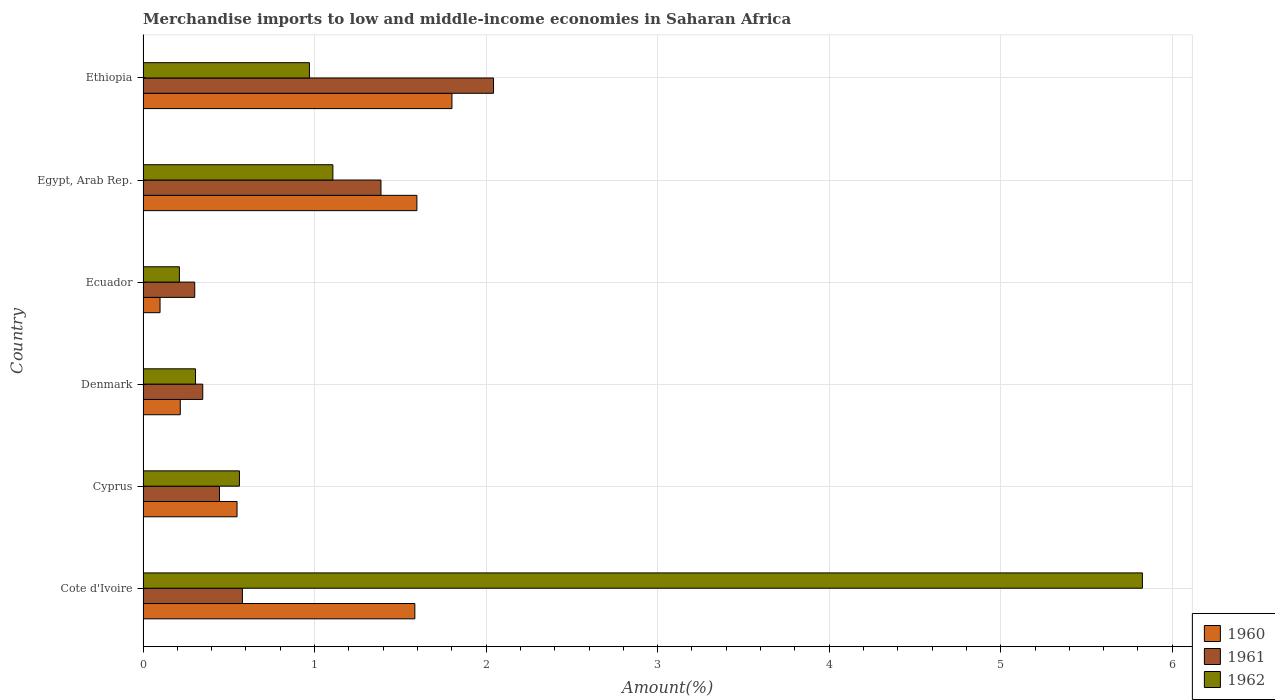Are the number of bars per tick equal to the number of legend labels?
Keep it short and to the point. Yes. Are the number of bars on each tick of the Y-axis equal?
Your answer should be compact. Yes. How many bars are there on the 4th tick from the top?
Offer a terse response. 3. How many bars are there on the 1st tick from the bottom?
Keep it short and to the point. 3. What is the label of the 5th group of bars from the top?
Make the answer very short. Cyprus. In how many cases, is the number of bars for a given country not equal to the number of legend labels?
Keep it short and to the point. 0. What is the percentage of amount earned from merchandise imports in 1962 in Cyprus?
Offer a very short reply. 0.56. Across all countries, what is the maximum percentage of amount earned from merchandise imports in 1961?
Keep it short and to the point. 2.04. Across all countries, what is the minimum percentage of amount earned from merchandise imports in 1960?
Make the answer very short. 0.1. In which country was the percentage of amount earned from merchandise imports in 1961 maximum?
Make the answer very short. Ethiopia. In which country was the percentage of amount earned from merchandise imports in 1962 minimum?
Your response must be concise. Ecuador. What is the total percentage of amount earned from merchandise imports in 1960 in the graph?
Your response must be concise. 5.85. What is the difference between the percentage of amount earned from merchandise imports in 1962 in Cote d'Ivoire and that in Cyprus?
Your answer should be compact. 5.26. What is the difference between the percentage of amount earned from merchandise imports in 1961 in Cyprus and the percentage of amount earned from merchandise imports in 1962 in Ethiopia?
Your answer should be compact. -0.52. What is the average percentage of amount earned from merchandise imports in 1961 per country?
Make the answer very short. 0.85. What is the difference between the percentage of amount earned from merchandise imports in 1960 and percentage of amount earned from merchandise imports in 1961 in Ecuador?
Your answer should be compact. -0.2. In how many countries, is the percentage of amount earned from merchandise imports in 1962 greater than 5.8 %?
Offer a terse response. 1. What is the ratio of the percentage of amount earned from merchandise imports in 1962 in Cyprus to that in Egypt, Arab Rep.?
Offer a very short reply. 0.51. Is the percentage of amount earned from merchandise imports in 1962 in Ecuador less than that in Ethiopia?
Provide a short and direct response. Yes. Is the difference between the percentage of amount earned from merchandise imports in 1960 in Cote d'Ivoire and Egypt, Arab Rep. greater than the difference between the percentage of amount earned from merchandise imports in 1961 in Cote d'Ivoire and Egypt, Arab Rep.?
Make the answer very short. Yes. What is the difference between the highest and the second highest percentage of amount earned from merchandise imports in 1961?
Give a very brief answer. 0.66. What is the difference between the highest and the lowest percentage of amount earned from merchandise imports in 1960?
Provide a succinct answer. 1.7. Is the sum of the percentage of amount earned from merchandise imports in 1961 in Cyprus and Ecuador greater than the maximum percentage of amount earned from merchandise imports in 1960 across all countries?
Your answer should be compact. No. Is it the case that in every country, the sum of the percentage of amount earned from merchandise imports in 1961 and percentage of amount earned from merchandise imports in 1962 is greater than the percentage of amount earned from merchandise imports in 1960?
Make the answer very short. Yes. How many bars are there?
Give a very brief answer. 18. How many countries are there in the graph?
Give a very brief answer. 6. What is the difference between two consecutive major ticks on the X-axis?
Your answer should be very brief. 1. Are the values on the major ticks of X-axis written in scientific E-notation?
Provide a short and direct response. No. Does the graph contain grids?
Offer a terse response. Yes. How many legend labels are there?
Make the answer very short. 3. How are the legend labels stacked?
Give a very brief answer. Vertical. What is the title of the graph?
Provide a succinct answer. Merchandise imports to low and middle-income economies in Saharan Africa. What is the label or title of the X-axis?
Your response must be concise. Amount(%). What is the label or title of the Y-axis?
Your answer should be compact. Country. What is the Amount(%) in 1960 in Cote d'Ivoire?
Offer a very short reply. 1.58. What is the Amount(%) in 1961 in Cote d'Ivoire?
Your response must be concise. 0.58. What is the Amount(%) of 1962 in Cote d'Ivoire?
Your answer should be very brief. 5.83. What is the Amount(%) of 1960 in Cyprus?
Keep it short and to the point. 0.55. What is the Amount(%) of 1961 in Cyprus?
Your answer should be very brief. 0.45. What is the Amount(%) of 1962 in Cyprus?
Your answer should be very brief. 0.56. What is the Amount(%) in 1960 in Denmark?
Offer a terse response. 0.22. What is the Amount(%) of 1961 in Denmark?
Your response must be concise. 0.35. What is the Amount(%) of 1962 in Denmark?
Your response must be concise. 0.31. What is the Amount(%) in 1960 in Ecuador?
Offer a very short reply. 0.1. What is the Amount(%) of 1961 in Ecuador?
Give a very brief answer. 0.3. What is the Amount(%) of 1962 in Ecuador?
Provide a short and direct response. 0.21. What is the Amount(%) in 1960 in Egypt, Arab Rep.?
Your answer should be very brief. 1.6. What is the Amount(%) in 1961 in Egypt, Arab Rep.?
Give a very brief answer. 1.39. What is the Amount(%) of 1962 in Egypt, Arab Rep.?
Ensure brevity in your answer.  1.11. What is the Amount(%) of 1960 in Ethiopia?
Provide a succinct answer. 1.8. What is the Amount(%) of 1961 in Ethiopia?
Give a very brief answer. 2.04. What is the Amount(%) of 1962 in Ethiopia?
Make the answer very short. 0.97. Across all countries, what is the maximum Amount(%) in 1960?
Offer a very short reply. 1.8. Across all countries, what is the maximum Amount(%) in 1961?
Offer a very short reply. 2.04. Across all countries, what is the maximum Amount(%) of 1962?
Offer a terse response. 5.83. Across all countries, what is the minimum Amount(%) of 1960?
Make the answer very short. 0.1. Across all countries, what is the minimum Amount(%) of 1961?
Your response must be concise. 0.3. Across all countries, what is the minimum Amount(%) of 1962?
Keep it short and to the point. 0.21. What is the total Amount(%) in 1960 in the graph?
Keep it short and to the point. 5.85. What is the total Amount(%) of 1961 in the graph?
Offer a terse response. 5.1. What is the total Amount(%) of 1962 in the graph?
Keep it short and to the point. 8.98. What is the difference between the Amount(%) of 1960 in Cote d'Ivoire and that in Cyprus?
Provide a succinct answer. 1.04. What is the difference between the Amount(%) of 1961 in Cote d'Ivoire and that in Cyprus?
Offer a terse response. 0.13. What is the difference between the Amount(%) in 1962 in Cote d'Ivoire and that in Cyprus?
Offer a terse response. 5.26. What is the difference between the Amount(%) in 1960 in Cote d'Ivoire and that in Denmark?
Make the answer very short. 1.37. What is the difference between the Amount(%) of 1961 in Cote d'Ivoire and that in Denmark?
Give a very brief answer. 0.23. What is the difference between the Amount(%) in 1962 in Cote d'Ivoire and that in Denmark?
Offer a terse response. 5.52. What is the difference between the Amount(%) in 1960 in Cote d'Ivoire and that in Ecuador?
Provide a succinct answer. 1.49. What is the difference between the Amount(%) of 1961 in Cote d'Ivoire and that in Ecuador?
Offer a terse response. 0.28. What is the difference between the Amount(%) of 1962 in Cote d'Ivoire and that in Ecuador?
Offer a terse response. 5.61. What is the difference between the Amount(%) in 1960 in Cote d'Ivoire and that in Egypt, Arab Rep.?
Ensure brevity in your answer.  -0.01. What is the difference between the Amount(%) in 1961 in Cote d'Ivoire and that in Egypt, Arab Rep.?
Make the answer very short. -0.81. What is the difference between the Amount(%) in 1962 in Cote d'Ivoire and that in Egypt, Arab Rep.?
Your answer should be compact. 4.72. What is the difference between the Amount(%) in 1960 in Cote d'Ivoire and that in Ethiopia?
Your response must be concise. -0.22. What is the difference between the Amount(%) of 1961 in Cote d'Ivoire and that in Ethiopia?
Your answer should be very brief. -1.46. What is the difference between the Amount(%) of 1962 in Cote d'Ivoire and that in Ethiopia?
Your response must be concise. 4.86. What is the difference between the Amount(%) of 1960 in Cyprus and that in Denmark?
Provide a short and direct response. 0.33. What is the difference between the Amount(%) in 1961 in Cyprus and that in Denmark?
Offer a very short reply. 0.1. What is the difference between the Amount(%) of 1962 in Cyprus and that in Denmark?
Provide a succinct answer. 0.26. What is the difference between the Amount(%) in 1960 in Cyprus and that in Ecuador?
Your response must be concise. 0.45. What is the difference between the Amount(%) of 1961 in Cyprus and that in Ecuador?
Offer a terse response. 0.14. What is the difference between the Amount(%) in 1962 in Cyprus and that in Ecuador?
Keep it short and to the point. 0.35. What is the difference between the Amount(%) of 1960 in Cyprus and that in Egypt, Arab Rep.?
Your answer should be very brief. -1.05. What is the difference between the Amount(%) in 1961 in Cyprus and that in Egypt, Arab Rep.?
Your answer should be compact. -0.94. What is the difference between the Amount(%) of 1962 in Cyprus and that in Egypt, Arab Rep.?
Your response must be concise. -0.54. What is the difference between the Amount(%) in 1960 in Cyprus and that in Ethiopia?
Your response must be concise. -1.25. What is the difference between the Amount(%) in 1961 in Cyprus and that in Ethiopia?
Provide a short and direct response. -1.6. What is the difference between the Amount(%) of 1962 in Cyprus and that in Ethiopia?
Keep it short and to the point. -0.41. What is the difference between the Amount(%) in 1960 in Denmark and that in Ecuador?
Provide a short and direct response. 0.12. What is the difference between the Amount(%) of 1961 in Denmark and that in Ecuador?
Offer a terse response. 0.05. What is the difference between the Amount(%) of 1962 in Denmark and that in Ecuador?
Offer a terse response. 0.09. What is the difference between the Amount(%) in 1960 in Denmark and that in Egypt, Arab Rep.?
Provide a short and direct response. -1.38. What is the difference between the Amount(%) in 1961 in Denmark and that in Egypt, Arab Rep.?
Make the answer very short. -1.04. What is the difference between the Amount(%) in 1962 in Denmark and that in Egypt, Arab Rep.?
Your response must be concise. -0.8. What is the difference between the Amount(%) in 1960 in Denmark and that in Ethiopia?
Your answer should be compact. -1.58. What is the difference between the Amount(%) in 1961 in Denmark and that in Ethiopia?
Offer a very short reply. -1.7. What is the difference between the Amount(%) in 1962 in Denmark and that in Ethiopia?
Ensure brevity in your answer.  -0.66. What is the difference between the Amount(%) in 1960 in Ecuador and that in Egypt, Arab Rep.?
Offer a very short reply. -1.5. What is the difference between the Amount(%) in 1961 in Ecuador and that in Egypt, Arab Rep.?
Provide a succinct answer. -1.09. What is the difference between the Amount(%) of 1962 in Ecuador and that in Egypt, Arab Rep.?
Offer a very short reply. -0.89. What is the difference between the Amount(%) of 1960 in Ecuador and that in Ethiopia?
Provide a short and direct response. -1.7. What is the difference between the Amount(%) of 1961 in Ecuador and that in Ethiopia?
Offer a terse response. -1.74. What is the difference between the Amount(%) of 1962 in Ecuador and that in Ethiopia?
Ensure brevity in your answer.  -0.76. What is the difference between the Amount(%) in 1960 in Egypt, Arab Rep. and that in Ethiopia?
Ensure brevity in your answer.  -0.2. What is the difference between the Amount(%) of 1961 in Egypt, Arab Rep. and that in Ethiopia?
Provide a succinct answer. -0.66. What is the difference between the Amount(%) in 1962 in Egypt, Arab Rep. and that in Ethiopia?
Ensure brevity in your answer.  0.14. What is the difference between the Amount(%) in 1960 in Cote d'Ivoire and the Amount(%) in 1961 in Cyprus?
Make the answer very short. 1.14. What is the difference between the Amount(%) in 1960 in Cote d'Ivoire and the Amount(%) in 1962 in Cyprus?
Provide a succinct answer. 1.02. What is the difference between the Amount(%) in 1961 in Cote d'Ivoire and the Amount(%) in 1962 in Cyprus?
Your answer should be compact. 0.02. What is the difference between the Amount(%) in 1960 in Cote d'Ivoire and the Amount(%) in 1961 in Denmark?
Make the answer very short. 1.24. What is the difference between the Amount(%) of 1960 in Cote d'Ivoire and the Amount(%) of 1962 in Denmark?
Ensure brevity in your answer.  1.28. What is the difference between the Amount(%) of 1961 in Cote d'Ivoire and the Amount(%) of 1962 in Denmark?
Your answer should be very brief. 0.27. What is the difference between the Amount(%) in 1960 in Cote d'Ivoire and the Amount(%) in 1961 in Ecuador?
Your answer should be compact. 1.28. What is the difference between the Amount(%) in 1960 in Cote d'Ivoire and the Amount(%) in 1962 in Ecuador?
Provide a short and direct response. 1.37. What is the difference between the Amount(%) of 1961 in Cote d'Ivoire and the Amount(%) of 1962 in Ecuador?
Make the answer very short. 0.37. What is the difference between the Amount(%) in 1960 in Cote d'Ivoire and the Amount(%) in 1961 in Egypt, Arab Rep.?
Your answer should be compact. 0.2. What is the difference between the Amount(%) in 1960 in Cote d'Ivoire and the Amount(%) in 1962 in Egypt, Arab Rep.?
Your answer should be compact. 0.48. What is the difference between the Amount(%) in 1961 in Cote d'Ivoire and the Amount(%) in 1962 in Egypt, Arab Rep.?
Offer a very short reply. -0.53. What is the difference between the Amount(%) of 1960 in Cote d'Ivoire and the Amount(%) of 1961 in Ethiopia?
Your answer should be compact. -0.46. What is the difference between the Amount(%) of 1960 in Cote d'Ivoire and the Amount(%) of 1962 in Ethiopia?
Make the answer very short. 0.61. What is the difference between the Amount(%) in 1961 in Cote d'Ivoire and the Amount(%) in 1962 in Ethiopia?
Keep it short and to the point. -0.39. What is the difference between the Amount(%) of 1960 in Cyprus and the Amount(%) of 1961 in Denmark?
Ensure brevity in your answer.  0.2. What is the difference between the Amount(%) of 1960 in Cyprus and the Amount(%) of 1962 in Denmark?
Your answer should be very brief. 0.24. What is the difference between the Amount(%) in 1961 in Cyprus and the Amount(%) in 1962 in Denmark?
Offer a very short reply. 0.14. What is the difference between the Amount(%) in 1960 in Cyprus and the Amount(%) in 1961 in Ecuador?
Ensure brevity in your answer.  0.25. What is the difference between the Amount(%) of 1960 in Cyprus and the Amount(%) of 1962 in Ecuador?
Offer a terse response. 0.34. What is the difference between the Amount(%) of 1961 in Cyprus and the Amount(%) of 1962 in Ecuador?
Your answer should be compact. 0.23. What is the difference between the Amount(%) of 1960 in Cyprus and the Amount(%) of 1961 in Egypt, Arab Rep.?
Make the answer very short. -0.84. What is the difference between the Amount(%) in 1960 in Cyprus and the Amount(%) in 1962 in Egypt, Arab Rep.?
Provide a succinct answer. -0.56. What is the difference between the Amount(%) in 1961 in Cyprus and the Amount(%) in 1962 in Egypt, Arab Rep.?
Offer a very short reply. -0.66. What is the difference between the Amount(%) in 1960 in Cyprus and the Amount(%) in 1961 in Ethiopia?
Provide a succinct answer. -1.5. What is the difference between the Amount(%) in 1960 in Cyprus and the Amount(%) in 1962 in Ethiopia?
Keep it short and to the point. -0.42. What is the difference between the Amount(%) in 1961 in Cyprus and the Amount(%) in 1962 in Ethiopia?
Ensure brevity in your answer.  -0.52. What is the difference between the Amount(%) in 1960 in Denmark and the Amount(%) in 1961 in Ecuador?
Offer a very short reply. -0.08. What is the difference between the Amount(%) in 1960 in Denmark and the Amount(%) in 1962 in Ecuador?
Your response must be concise. 0.01. What is the difference between the Amount(%) in 1961 in Denmark and the Amount(%) in 1962 in Ecuador?
Ensure brevity in your answer.  0.14. What is the difference between the Amount(%) of 1960 in Denmark and the Amount(%) of 1961 in Egypt, Arab Rep.?
Give a very brief answer. -1.17. What is the difference between the Amount(%) in 1960 in Denmark and the Amount(%) in 1962 in Egypt, Arab Rep.?
Keep it short and to the point. -0.89. What is the difference between the Amount(%) of 1961 in Denmark and the Amount(%) of 1962 in Egypt, Arab Rep.?
Give a very brief answer. -0.76. What is the difference between the Amount(%) of 1960 in Denmark and the Amount(%) of 1961 in Ethiopia?
Make the answer very short. -1.83. What is the difference between the Amount(%) of 1960 in Denmark and the Amount(%) of 1962 in Ethiopia?
Your answer should be compact. -0.75. What is the difference between the Amount(%) of 1961 in Denmark and the Amount(%) of 1962 in Ethiopia?
Keep it short and to the point. -0.62. What is the difference between the Amount(%) in 1960 in Ecuador and the Amount(%) in 1961 in Egypt, Arab Rep.?
Give a very brief answer. -1.29. What is the difference between the Amount(%) in 1960 in Ecuador and the Amount(%) in 1962 in Egypt, Arab Rep.?
Your answer should be very brief. -1.01. What is the difference between the Amount(%) in 1961 in Ecuador and the Amount(%) in 1962 in Egypt, Arab Rep.?
Offer a very short reply. -0.81. What is the difference between the Amount(%) of 1960 in Ecuador and the Amount(%) of 1961 in Ethiopia?
Offer a very short reply. -1.94. What is the difference between the Amount(%) in 1960 in Ecuador and the Amount(%) in 1962 in Ethiopia?
Make the answer very short. -0.87. What is the difference between the Amount(%) in 1961 in Ecuador and the Amount(%) in 1962 in Ethiopia?
Provide a short and direct response. -0.67. What is the difference between the Amount(%) in 1960 in Egypt, Arab Rep. and the Amount(%) in 1961 in Ethiopia?
Provide a succinct answer. -0.45. What is the difference between the Amount(%) of 1960 in Egypt, Arab Rep. and the Amount(%) of 1962 in Ethiopia?
Offer a terse response. 0.63. What is the difference between the Amount(%) in 1961 in Egypt, Arab Rep. and the Amount(%) in 1962 in Ethiopia?
Provide a succinct answer. 0.42. What is the average Amount(%) of 1960 per country?
Ensure brevity in your answer.  0.97. What is the average Amount(%) in 1961 per country?
Keep it short and to the point. 0.85. What is the average Amount(%) in 1962 per country?
Provide a succinct answer. 1.5. What is the difference between the Amount(%) in 1960 and Amount(%) in 1961 in Cote d'Ivoire?
Provide a short and direct response. 1.01. What is the difference between the Amount(%) in 1960 and Amount(%) in 1962 in Cote d'Ivoire?
Your answer should be very brief. -4.24. What is the difference between the Amount(%) in 1961 and Amount(%) in 1962 in Cote d'Ivoire?
Offer a very short reply. -5.25. What is the difference between the Amount(%) in 1960 and Amount(%) in 1961 in Cyprus?
Your response must be concise. 0.1. What is the difference between the Amount(%) in 1960 and Amount(%) in 1962 in Cyprus?
Provide a succinct answer. -0.01. What is the difference between the Amount(%) of 1961 and Amount(%) of 1962 in Cyprus?
Ensure brevity in your answer.  -0.12. What is the difference between the Amount(%) in 1960 and Amount(%) in 1961 in Denmark?
Offer a terse response. -0.13. What is the difference between the Amount(%) of 1960 and Amount(%) of 1962 in Denmark?
Ensure brevity in your answer.  -0.09. What is the difference between the Amount(%) of 1961 and Amount(%) of 1962 in Denmark?
Keep it short and to the point. 0.04. What is the difference between the Amount(%) in 1960 and Amount(%) in 1961 in Ecuador?
Your answer should be compact. -0.2. What is the difference between the Amount(%) of 1960 and Amount(%) of 1962 in Ecuador?
Ensure brevity in your answer.  -0.11. What is the difference between the Amount(%) in 1961 and Amount(%) in 1962 in Ecuador?
Your answer should be compact. 0.09. What is the difference between the Amount(%) of 1960 and Amount(%) of 1961 in Egypt, Arab Rep.?
Give a very brief answer. 0.21. What is the difference between the Amount(%) of 1960 and Amount(%) of 1962 in Egypt, Arab Rep.?
Offer a very short reply. 0.49. What is the difference between the Amount(%) in 1961 and Amount(%) in 1962 in Egypt, Arab Rep.?
Your answer should be compact. 0.28. What is the difference between the Amount(%) in 1960 and Amount(%) in 1961 in Ethiopia?
Keep it short and to the point. -0.24. What is the difference between the Amount(%) of 1960 and Amount(%) of 1962 in Ethiopia?
Keep it short and to the point. 0.83. What is the difference between the Amount(%) in 1961 and Amount(%) in 1962 in Ethiopia?
Provide a succinct answer. 1.07. What is the ratio of the Amount(%) in 1960 in Cote d'Ivoire to that in Cyprus?
Ensure brevity in your answer.  2.89. What is the ratio of the Amount(%) in 1961 in Cote d'Ivoire to that in Cyprus?
Make the answer very short. 1.3. What is the ratio of the Amount(%) of 1962 in Cote d'Ivoire to that in Cyprus?
Your response must be concise. 10.37. What is the ratio of the Amount(%) in 1960 in Cote d'Ivoire to that in Denmark?
Offer a terse response. 7.3. What is the ratio of the Amount(%) in 1961 in Cote d'Ivoire to that in Denmark?
Your answer should be compact. 1.66. What is the ratio of the Amount(%) of 1962 in Cote d'Ivoire to that in Denmark?
Ensure brevity in your answer.  19.05. What is the ratio of the Amount(%) in 1960 in Cote d'Ivoire to that in Ecuador?
Your response must be concise. 16. What is the ratio of the Amount(%) of 1961 in Cote d'Ivoire to that in Ecuador?
Keep it short and to the point. 1.92. What is the ratio of the Amount(%) of 1962 in Cote d'Ivoire to that in Ecuador?
Offer a very short reply. 27.5. What is the ratio of the Amount(%) in 1961 in Cote d'Ivoire to that in Egypt, Arab Rep.?
Give a very brief answer. 0.42. What is the ratio of the Amount(%) in 1962 in Cote d'Ivoire to that in Egypt, Arab Rep.?
Offer a terse response. 5.26. What is the ratio of the Amount(%) of 1960 in Cote d'Ivoire to that in Ethiopia?
Offer a very short reply. 0.88. What is the ratio of the Amount(%) in 1961 in Cote d'Ivoire to that in Ethiopia?
Your answer should be compact. 0.28. What is the ratio of the Amount(%) of 1962 in Cote d'Ivoire to that in Ethiopia?
Provide a succinct answer. 6.01. What is the ratio of the Amount(%) of 1960 in Cyprus to that in Denmark?
Offer a terse response. 2.53. What is the ratio of the Amount(%) of 1961 in Cyprus to that in Denmark?
Ensure brevity in your answer.  1.28. What is the ratio of the Amount(%) in 1962 in Cyprus to that in Denmark?
Your response must be concise. 1.84. What is the ratio of the Amount(%) of 1960 in Cyprus to that in Ecuador?
Offer a terse response. 5.53. What is the ratio of the Amount(%) in 1961 in Cyprus to that in Ecuador?
Provide a succinct answer. 1.48. What is the ratio of the Amount(%) in 1962 in Cyprus to that in Ecuador?
Your answer should be very brief. 2.65. What is the ratio of the Amount(%) of 1960 in Cyprus to that in Egypt, Arab Rep.?
Your answer should be compact. 0.34. What is the ratio of the Amount(%) of 1961 in Cyprus to that in Egypt, Arab Rep.?
Offer a very short reply. 0.32. What is the ratio of the Amount(%) of 1962 in Cyprus to that in Egypt, Arab Rep.?
Offer a terse response. 0.51. What is the ratio of the Amount(%) of 1960 in Cyprus to that in Ethiopia?
Provide a succinct answer. 0.3. What is the ratio of the Amount(%) of 1961 in Cyprus to that in Ethiopia?
Provide a succinct answer. 0.22. What is the ratio of the Amount(%) of 1962 in Cyprus to that in Ethiopia?
Provide a short and direct response. 0.58. What is the ratio of the Amount(%) in 1960 in Denmark to that in Ecuador?
Provide a succinct answer. 2.19. What is the ratio of the Amount(%) of 1961 in Denmark to that in Ecuador?
Keep it short and to the point. 1.16. What is the ratio of the Amount(%) of 1962 in Denmark to that in Ecuador?
Give a very brief answer. 1.44. What is the ratio of the Amount(%) of 1960 in Denmark to that in Egypt, Arab Rep.?
Offer a terse response. 0.14. What is the ratio of the Amount(%) in 1961 in Denmark to that in Egypt, Arab Rep.?
Make the answer very short. 0.25. What is the ratio of the Amount(%) in 1962 in Denmark to that in Egypt, Arab Rep.?
Give a very brief answer. 0.28. What is the ratio of the Amount(%) in 1960 in Denmark to that in Ethiopia?
Your answer should be very brief. 0.12. What is the ratio of the Amount(%) in 1961 in Denmark to that in Ethiopia?
Give a very brief answer. 0.17. What is the ratio of the Amount(%) of 1962 in Denmark to that in Ethiopia?
Provide a short and direct response. 0.32. What is the ratio of the Amount(%) of 1960 in Ecuador to that in Egypt, Arab Rep.?
Your response must be concise. 0.06. What is the ratio of the Amount(%) in 1961 in Ecuador to that in Egypt, Arab Rep.?
Keep it short and to the point. 0.22. What is the ratio of the Amount(%) of 1962 in Ecuador to that in Egypt, Arab Rep.?
Make the answer very short. 0.19. What is the ratio of the Amount(%) of 1960 in Ecuador to that in Ethiopia?
Your answer should be compact. 0.06. What is the ratio of the Amount(%) of 1961 in Ecuador to that in Ethiopia?
Offer a terse response. 0.15. What is the ratio of the Amount(%) of 1962 in Ecuador to that in Ethiopia?
Provide a succinct answer. 0.22. What is the ratio of the Amount(%) of 1960 in Egypt, Arab Rep. to that in Ethiopia?
Provide a succinct answer. 0.89. What is the ratio of the Amount(%) in 1961 in Egypt, Arab Rep. to that in Ethiopia?
Offer a terse response. 0.68. What is the ratio of the Amount(%) in 1962 in Egypt, Arab Rep. to that in Ethiopia?
Keep it short and to the point. 1.14. What is the difference between the highest and the second highest Amount(%) of 1960?
Keep it short and to the point. 0.2. What is the difference between the highest and the second highest Amount(%) in 1961?
Keep it short and to the point. 0.66. What is the difference between the highest and the second highest Amount(%) in 1962?
Keep it short and to the point. 4.72. What is the difference between the highest and the lowest Amount(%) of 1960?
Your response must be concise. 1.7. What is the difference between the highest and the lowest Amount(%) of 1961?
Provide a short and direct response. 1.74. What is the difference between the highest and the lowest Amount(%) in 1962?
Ensure brevity in your answer.  5.61. 